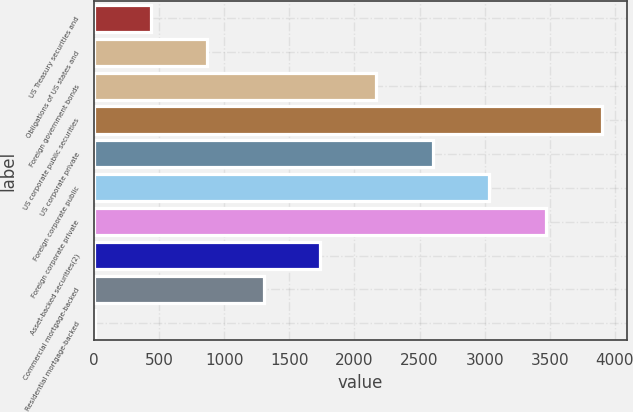Convert chart to OTSL. <chart><loc_0><loc_0><loc_500><loc_500><bar_chart><fcel>US Treasury securities and<fcel>Obligations of US states and<fcel>Foreign government bonds<fcel>US corporate public securities<fcel>US corporate private<fcel>Foreign corporate public<fcel>Foreign corporate private<fcel>Asset-backed securities(2)<fcel>Commercial mortgage-backed<fcel>Residential mortgage-backed<nl><fcel>438.7<fcel>871.4<fcel>2169.5<fcel>3900.3<fcel>2602.2<fcel>3034.9<fcel>3467.6<fcel>1736.8<fcel>1304.1<fcel>6<nl></chart> 